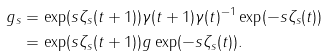<formula> <loc_0><loc_0><loc_500><loc_500>g _ { s } & = \exp ( s \zeta _ { s } ( t + 1 ) ) \gamma ( t + 1 ) \gamma ( t ) ^ { - 1 } \exp ( - s \zeta _ { s } ( t ) ) \\ & = \exp ( s \zeta _ { s } ( t + 1 ) ) g \exp ( - s \zeta _ { s } ( t ) ) .</formula> 